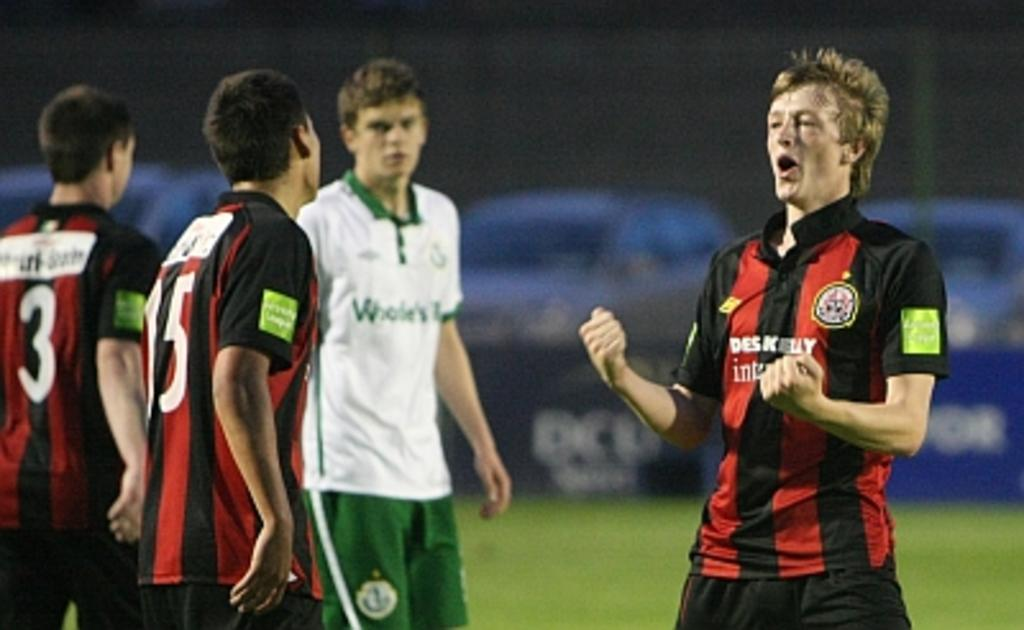Provide a one-sentence caption for the provided image. Player number 15 look at his teammate who is yelling. 